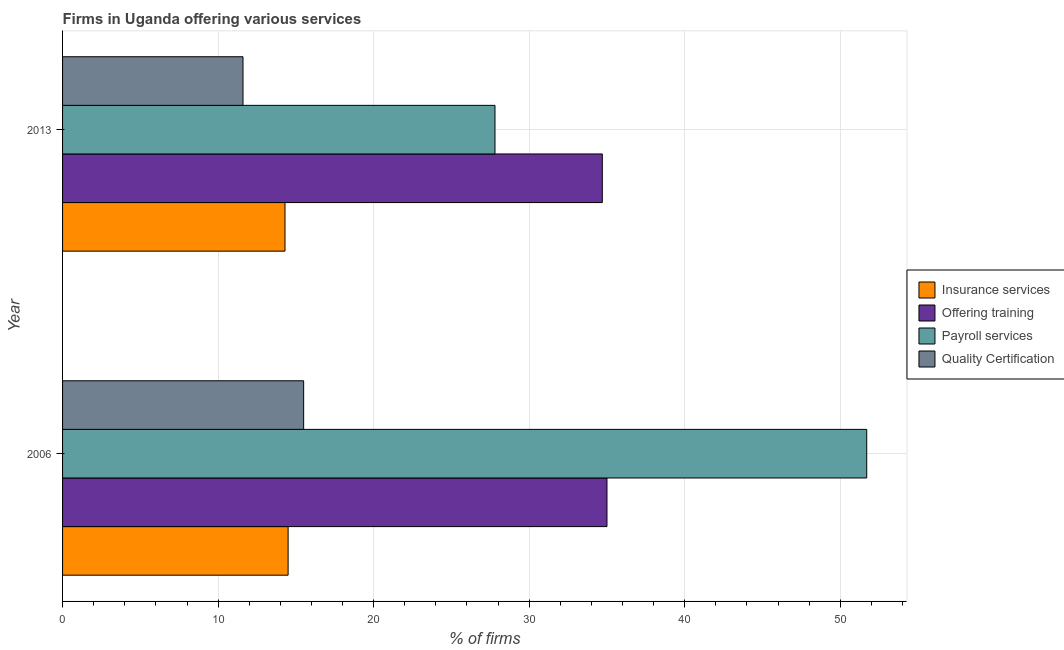Are the number of bars on each tick of the Y-axis equal?
Provide a short and direct response. Yes. How many bars are there on the 1st tick from the top?
Offer a very short reply. 4. How many bars are there on the 1st tick from the bottom?
Your response must be concise. 4. What is the label of the 2nd group of bars from the top?
Your answer should be compact. 2006. Across all years, what is the maximum percentage of firms offering training?
Make the answer very short. 35. Across all years, what is the minimum percentage of firms offering payroll services?
Ensure brevity in your answer.  27.8. In which year was the percentage of firms offering quality certification maximum?
Make the answer very short. 2006. In which year was the percentage of firms offering insurance services minimum?
Your answer should be very brief. 2013. What is the total percentage of firms offering insurance services in the graph?
Offer a very short reply. 28.8. What is the difference between the percentage of firms offering payroll services in 2013 and the percentage of firms offering training in 2006?
Offer a terse response. -7.2. What is the average percentage of firms offering quality certification per year?
Keep it short and to the point. 13.55. In the year 2013, what is the difference between the percentage of firms offering quality certification and percentage of firms offering training?
Provide a succinct answer. -23.1. In how many years, is the percentage of firms offering quality certification greater than 40 %?
Provide a succinct answer. 0. What is the ratio of the percentage of firms offering training in 2006 to that in 2013?
Your answer should be compact. 1.01. What does the 1st bar from the top in 2006 represents?
Make the answer very short. Quality Certification. What does the 4th bar from the bottom in 2006 represents?
Your answer should be compact. Quality Certification. Are all the bars in the graph horizontal?
Keep it short and to the point. Yes. How many years are there in the graph?
Your response must be concise. 2. Are the values on the major ticks of X-axis written in scientific E-notation?
Give a very brief answer. No. Does the graph contain grids?
Give a very brief answer. Yes. How many legend labels are there?
Provide a succinct answer. 4. How are the legend labels stacked?
Provide a succinct answer. Vertical. What is the title of the graph?
Your answer should be compact. Firms in Uganda offering various services . What is the label or title of the X-axis?
Provide a succinct answer. % of firms. What is the % of firms of Offering training in 2006?
Offer a very short reply. 35. What is the % of firms of Payroll services in 2006?
Your answer should be very brief. 51.7. What is the % of firms in Offering training in 2013?
Give a very brief answer. 34.7. What is the % of firms in Payroll services in 2013?
Provide a succinct answer. 27.8. Across all years, what is the maximum % of firms of Insurance services?
Your answer should be compact. 14.5. Across all years, what is the maximum % of firms of Offering training?
Offer a terse response. 35. Across all years, what is the maximum % of firms in Payroll services?
Provide a succinct answer. 51.7. Across all years, what is the maximum % of firms of Quality Certification?
Your answer should be very brief. 15.5. Across all years, what is the minimum % of firms in Offering training?
Your response must be concise. 34.7. Across all years, what is the minimum % of firms of Payroll services?
Your answer should be very brief. 27.8. What is the total % of firms in Insurance services in the graph?
Your answer should be very brief. 28.8. What is the total % of firms of Offering training in the graph?
Give a very brief answer. 69.7. What is the total % of firms of Payroll services in the graph?
Give a very brief answer. 79.5. What is the total % of firms in Quality Certification in the graph?
Provide a succinct answer. 27.1. What is the difference between the % of firms of Offering training in 2006 and that in 2013?
Provide a succinct answer. 0.3. What is the difference between the % of firms of Payroll services in 2006 and that in 2013?
Your response must be concise. 23.9. What is the difference between the % of firms of Insurance services in 2006 and the % of firms of Offering training in 2013?
Offer a terse response. -20.2. What is the difference between the % of firms of Insurance services in 2006 and the % of firms of Quality Certification in 2013?
Ensure brevity in your answer.  2.9. What is the difference between the % of firms in Offering training in 2006 and the % of firms in Payroll services in 2013?
Make the answer very short. 7.2. What is the difference between the % of firms of Offering training in 2006 and the % of firms of Quality Certification in 2013?
Offer a very short reply. 23.4. What is the difference between the % of firms of Payroll services in 2006 and the % of firms of Quality Certification in 2013?
Give a very brief answer. 40.1. What is the average % of firms in Offering training per year?
Offer a terse response. 34.85. What is the average % of firms in Payroll services per year?
Provide a succinct answer. 39.75. What is the average % of firms in Quality Certification per year?
Your response must be concise. 13.55. In the year 2006, what is the difference between the % of firms in Insurance services and % of firms in Offering training?
Provide a short and direct response. -20.5. In the year 2006, what is the difference between the % of firms of Insurance services and % of firms of Payroll services?
Keep it short and to the point. -37.2. In the year 2006, what is the difference between the % of firms of Insurance services and % of firms of Quality Certification?
Give a very brief answer. -1. In the year 2006, what is the difference between the % of firms in Offering training and % of firms in Payroll services?
Offer a very short reply. -16.7. In the year 2006, what is the difference between the % of firms in Payroll services and % of firms in Quality Certification?
Your response must be concise. 36.2. In the year 2013, what is the difference between the % of firms of Insurance services and % of firms of Offering training?
Your response must be concise. -20.4. In the year 2013, what is the difference between the % of firms of Insurance services and % of firms of Quality Certification?
Your response must be concise. 2.7. In the year 2013, what is the difference between the % of firms of Offering training and % of firms of Payroll services?
Make the answer very short. 6.9. In the year 2013, what is the difference between the % of firms of Offering training and % of firms of Quality Certification?
Your answer should be very brief. 23.1. In the year 2013, what is the difference between the % of firms of Payroll services and % of firms of Quality Certification?
Provide a short and direct response. 16.2. What is the ratio of the % of firms of Insurance services in 2006 to that in 2013?
Your answer should be very brief. 1.01. What is the ratio of the % of firms in Offering training in 2006 to that in 2013?
Your response must be concise. 1.01. What is the ratio of the % of firms of Payroll services in 2006 to that in 2013?
Ensure brevity in your answer.  1.86. What is the ratio of the % of firms of Quality Certification in 2006 to that in 2013?
Provide a succinct answer. 1.34. What is the difference between the highest and the second highest % of firms in Insurance services?
Ensure brevity in your answer.  0.2. What is the difference between the highest and the second highest % of firms in Payroll services?
Give a very brief answer. 23.9. What is the difference between the highest and the second highest % of firms in Quality Certification?
Offer a terse response. 3.9. What is the difference between the highest and the lowest % of firms in Insurance services?
Your answer should be very brief. 0.2. What is the difference between the highest and the lowest % of firms of Payroll services?
Ensure brevity in your answer.  23.9. What is the difference between the highest and the lowest % of firms of Quality Certification?
Keep it short and to the point. 3.9. 